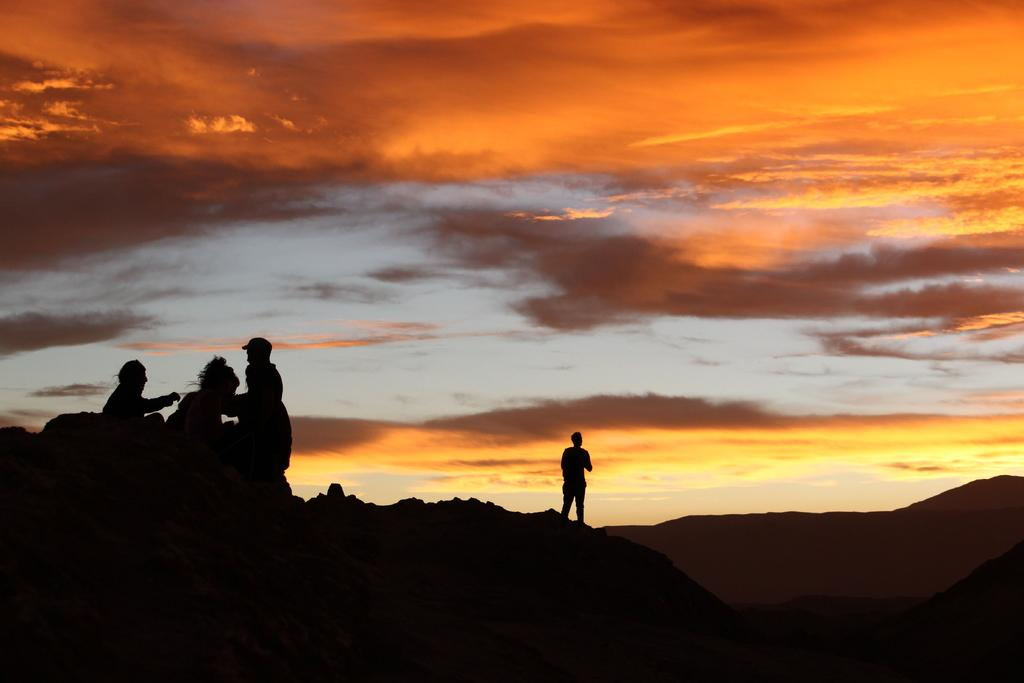What is the man doing in the image? The man is standing on a mountain in the image. Where are the other people located in the image? There are three persons sitting on a stone on the left side of the image. What can be seen at the top of the image? The sky is visible at the top of the image. What is the condition of the sky in the image? Clouds are present in the sky. What type of tomatoes can be seen growing on the mountain in the image? There are no tomatoes present in the image; it features a man standing on a mountain and three persons sitting on a stone. What is the chance of rain in the image? The image does not provide any information about the likelihood of rain; it only shows the sky with clouds. 